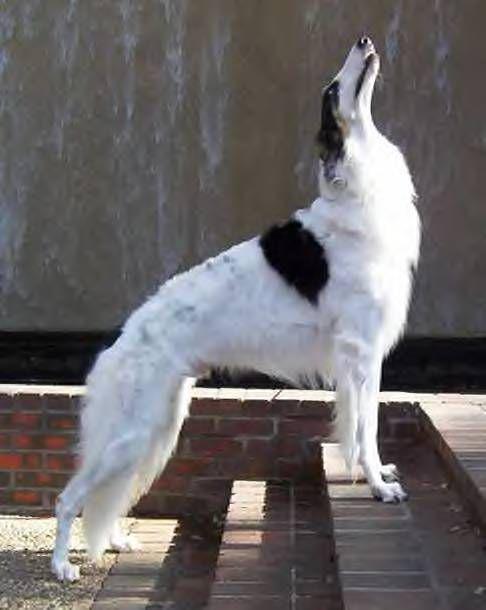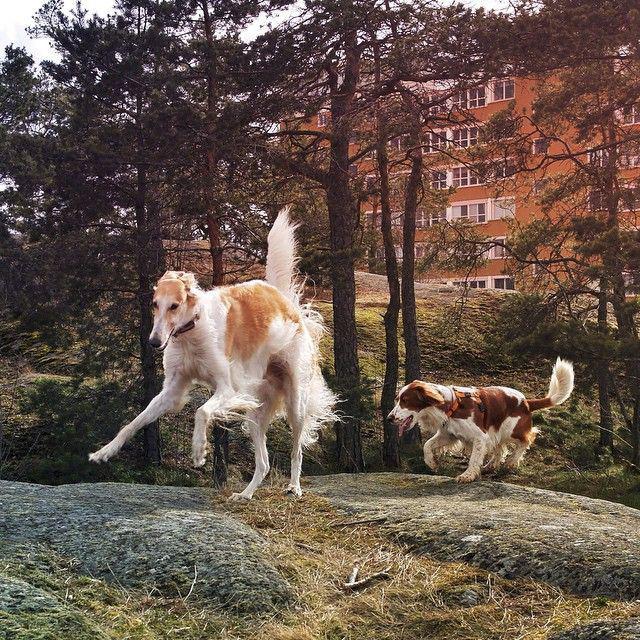The first image is the image on the left, the second image is the image on the right. For the images shown, is this caption "One image shows at least one dog reclining on a dark sofa with its muzzle pointed upward and its mouth slightly opened." true? Answer yes or no. No. The first image is the image on the left, the second image is the image on the right. For the images shown, is this caption "There is at least one Borzoi dog lying on a couch." true? Answer yes or no. No. 